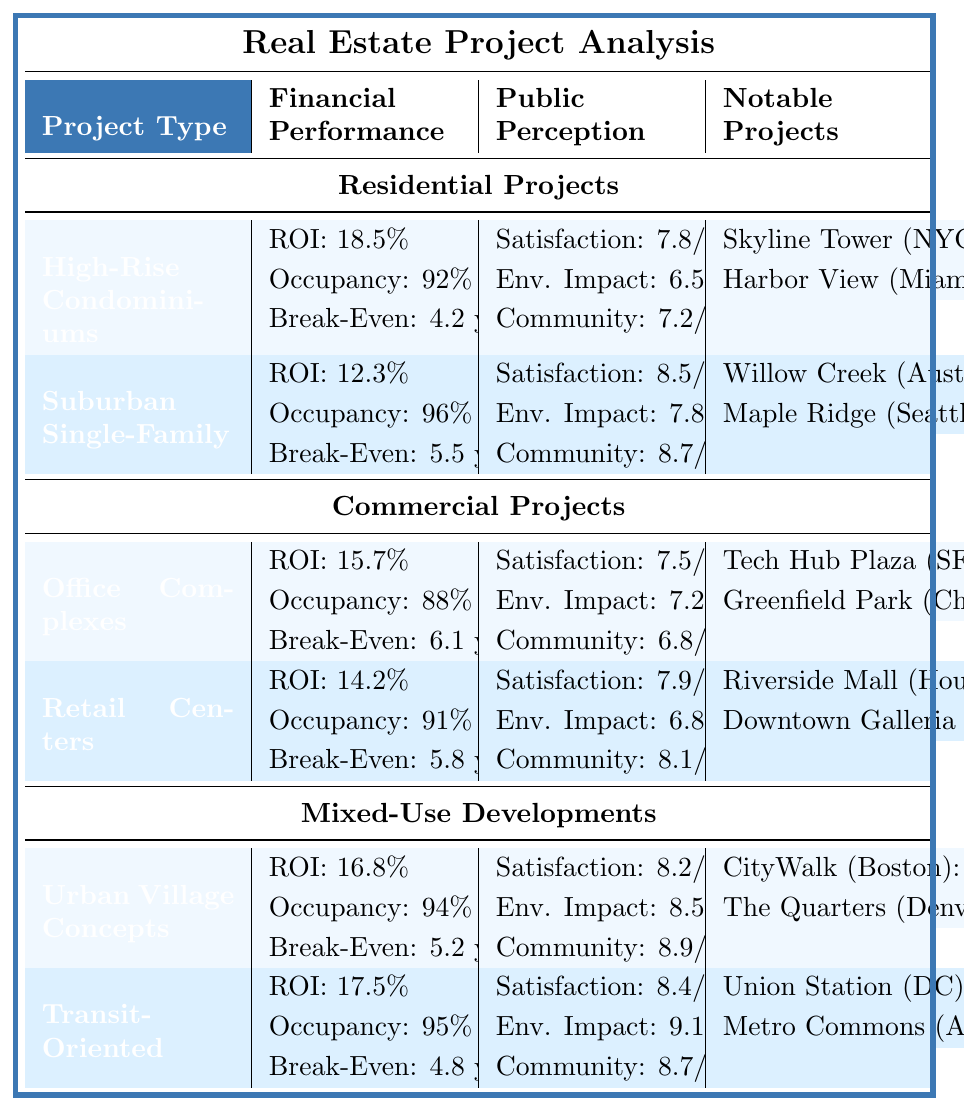What is the Average ROI for High-Rise Condominiums? The Average ROI for High-Rise Condominiums is listed as 18.5% in the table under the Financial Performance section.
Answer: 18.5% What is the Overall Satisfaction rating for Suburban Single-Family Homes? The Overall Satisfaction rating for Suburban Single-Family Homes is stated as 8.5/10 in the Public Perception section of the table.
Answer: 8.5/10 Which Commercial Project has the highest Public Approval Rating? The Notable Projects under Commercial Projects list Tech Hub Plaza in San Francisco with a Public Approval Rating of 79%, and Greenfield Business Park in Chicago with a rating of 74%. Therefore, Tech Hub Plaza has the highest rating at 79%.
Answer: Tech Hub Plaza (79%) What is the difference in Average ROI between Transit-Oriented Developments and Retail Centers? The Average ROI for Transit-Oriented Developments is 17.5%, while for Retail Centers it is 14.2%. The difference is calculated as 17.5% - 14.2% = 3.3%.
Answer: 3.3% Is the Environmental Impact Score for Urban Village Concepts higher than that for Office Complexes? Urban Village Concepts has an Environmental Impact Score of 8.5/10, while Office Complexes have a score of 7.2/10. Since 8.5 is greater than 7.2, the answer is yes.
Answer: Yes What is the total number of units in all Notable Projects listed for High-Rise Condominiums? For High-Rise Condominiums, the Notable Projects are Skyline Tower with 782 units and Harbor View Plaza with 560 units. The total is calculated as 782 + 560 = 1342.
Answer: 1342 units Which project type has the highest average Occupancy Rate? The table lists the Occupancy Rates as follows: High-Rise Condominiums: 92%, Suburban Single-Family Homes: 96%, Office Complexes: 88%, Retail Centers: 91%, Urban Village Concepts: 94%, and Transit-Oriented Developments: 95%. The highest rate is for Suburban Single-Family Homes at 96%.
Answer: Suburban Single-Family Homes How do the Overall Satisfaction ratings of Mixed-Use Developments compare to those of Commercial Projects? Mixed-Use Developments have an Overall Satisfaction rating of 8.3/10 (8.2 for Urban Village Concepts and 8.4 for Transit-Oriented Developments), while Commercial Projects have a satisfaction rating of 7.7/10 (7.5 for Office Complexes and 7.9 for Retail Centers). Comparing these averages shows that Mixed-Use Developments are rated higher.
Answer: Mixed-Use Developments are higher What is the Environmental Impact Score of the project with the highest Public Approval Rating among all listed projects? Union Station Square has the highest Public Approval Rating at 89% under Transit-Oriented Developments. Its Environmental Impact Score is 9.1/10.
Answer: 9.1/10 